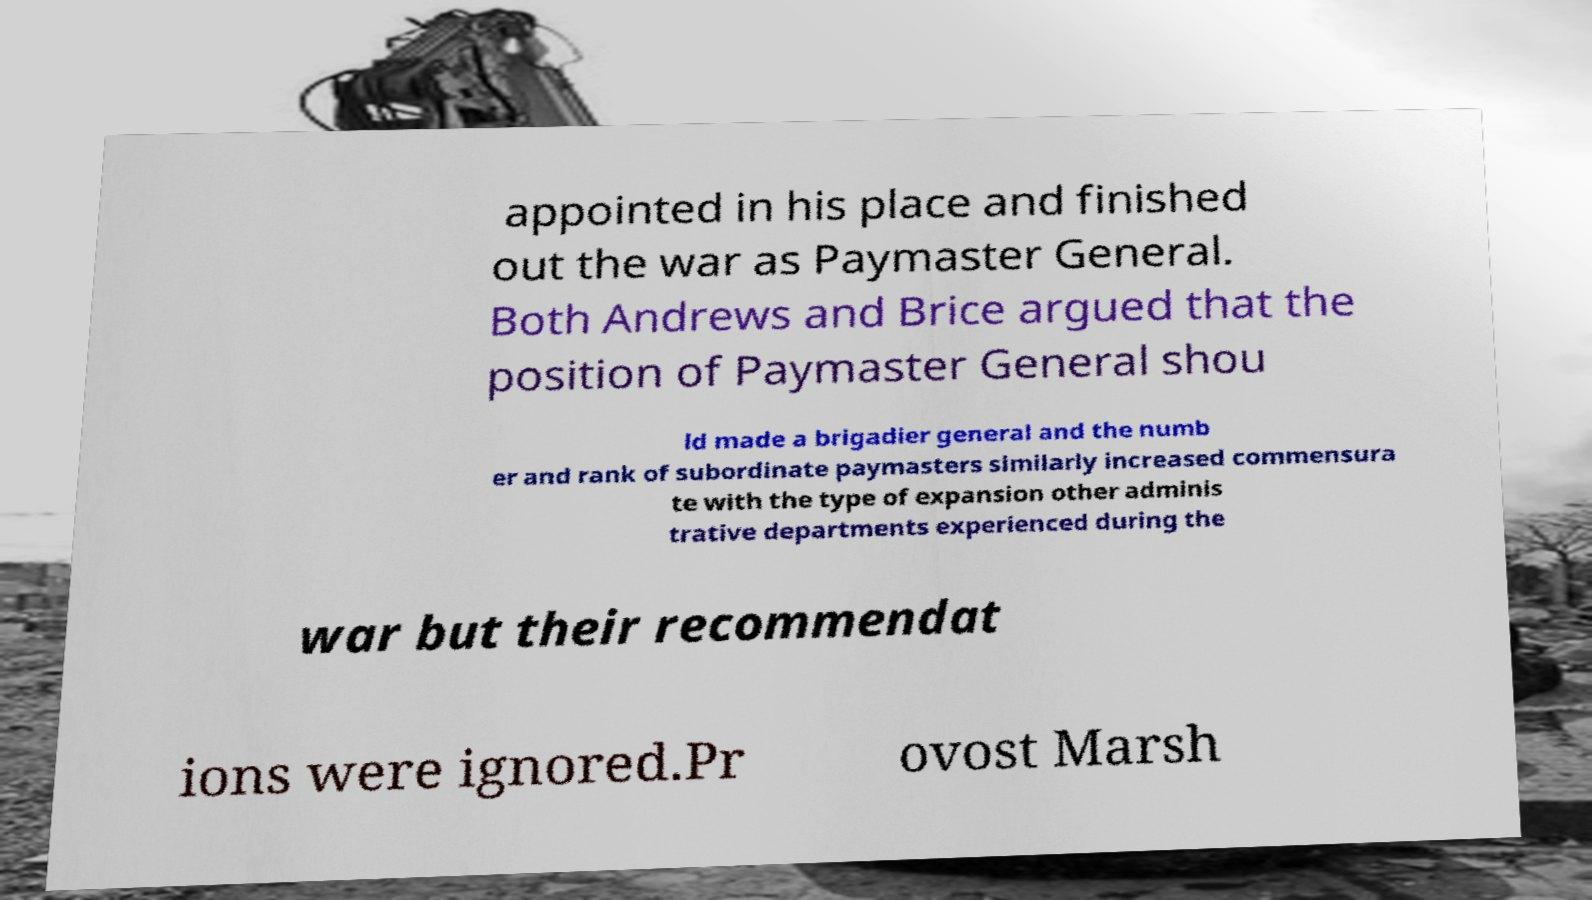There's text embedded in this image that I need extracted. Can you transcribe it verbatim? appointed in his place and finished out the war as Paymaster General. Both Andrews and Brice argued that the position of Paymaster General shou ld made a brigadier general and the numb er and rank of subordinate paymasters similarly increased commensura te with the type of expansion other adminis trative departments experienced during the war but their recommendat ions were ignored.Pr ovost Marsh 